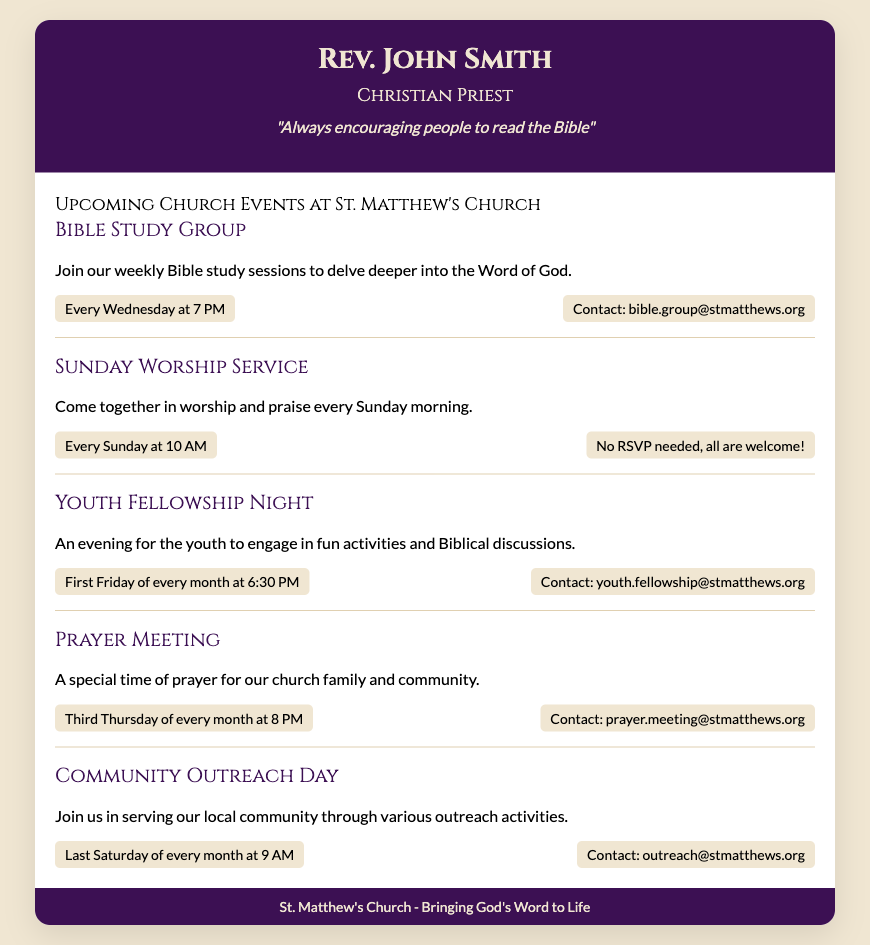What is the name of the priest? The name of the priest is highlighted at the top of the document.
Answer: Rev. John Smith What event occurs every Sunday? This event is specifically mentioned in the document as a weekly occurrence.
Answer: Sunday Worship Service What time does the Bible Study Group meet? The document specifies the meeting time for this event.
Answer: Every Wednesday at 7 PM How often is the Community Outreach Day held? This information is provided to indicate the frequency of the event.
Answer: Last Saturday of every month What is the contact email for Youth Fellowship Night? The document includes a specific email address for those interested in this event.
Answer: youth.fellowship@stmatthews.org What type of event is held on the third Thursday of every month? This event type can be inferred from the description provided in the document.
Answer: Prayer Meeting Which event requires no RSVP? The document states that this event does not need any prior arrangement.
Answer: Sunday Worship Service What is the main encouragement quote in the document? The header contains a motivational quote related to the priest's ministry.
Answer: "Always encouraging people to read the Bible" What is the purpose of the Community Outreach Day? The document provides a brief description of this event’s intent.
Answer: Serving our local community through various outreach activities 